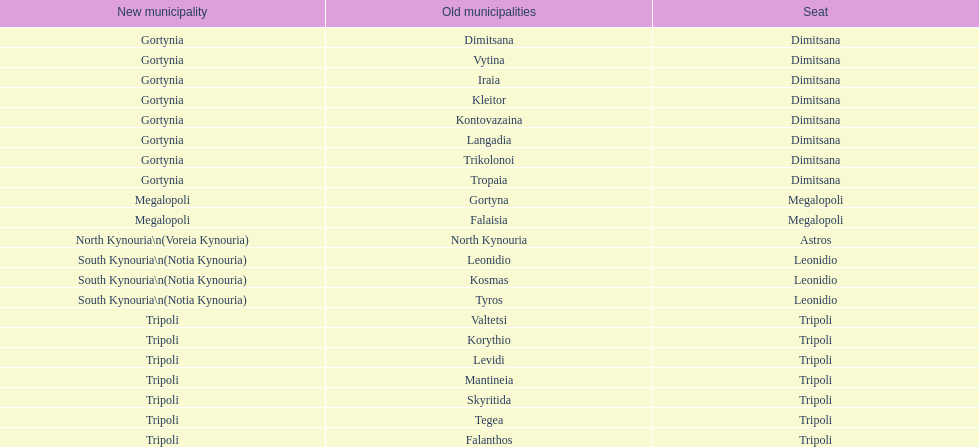What is the new municipality of tyros? South Kynouria. 